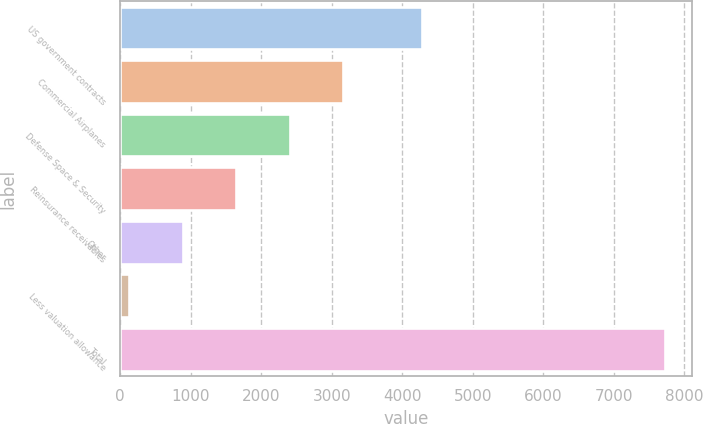Convert chart to OTSL. <chart><loc_0><loc_0><loc_500><loc_500><bar_chart><fcel>US government contracts<fcel>Commercial Airplanes<fcel>Defense Space & Security<fcel>Reinsurance receivables<fcel>Other<fcel>Less valuation allowance<fcel>Total<nl><fcel>4281<fcel>3167.8<fcel>2407.6<fcel>1647.4<fcel>887.2<fcel>127<fcel>7729<nl></chart> 